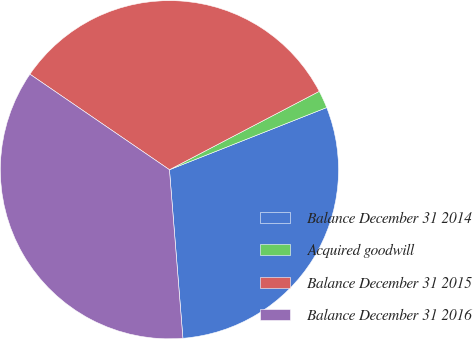Convert chart. <chart><loc_0><loc_0><loc_500><loc_500><pie_chart><fcel>Balance December 31 2014<fcel>Acquired goodwill<fcel>Balance December 31 2015<fcel>Balance December 31 2016<nl><fcel>29.72%<fcel>1.68%<fcel>32.77%<fcel>35.82%<nl></chart> 